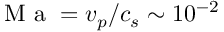<formula> <loc_0><loc_0><loc_500><loc_500>M a = v _ { p } / c _ { s } \sim 1 0 ^ { - 2 }</formula> 